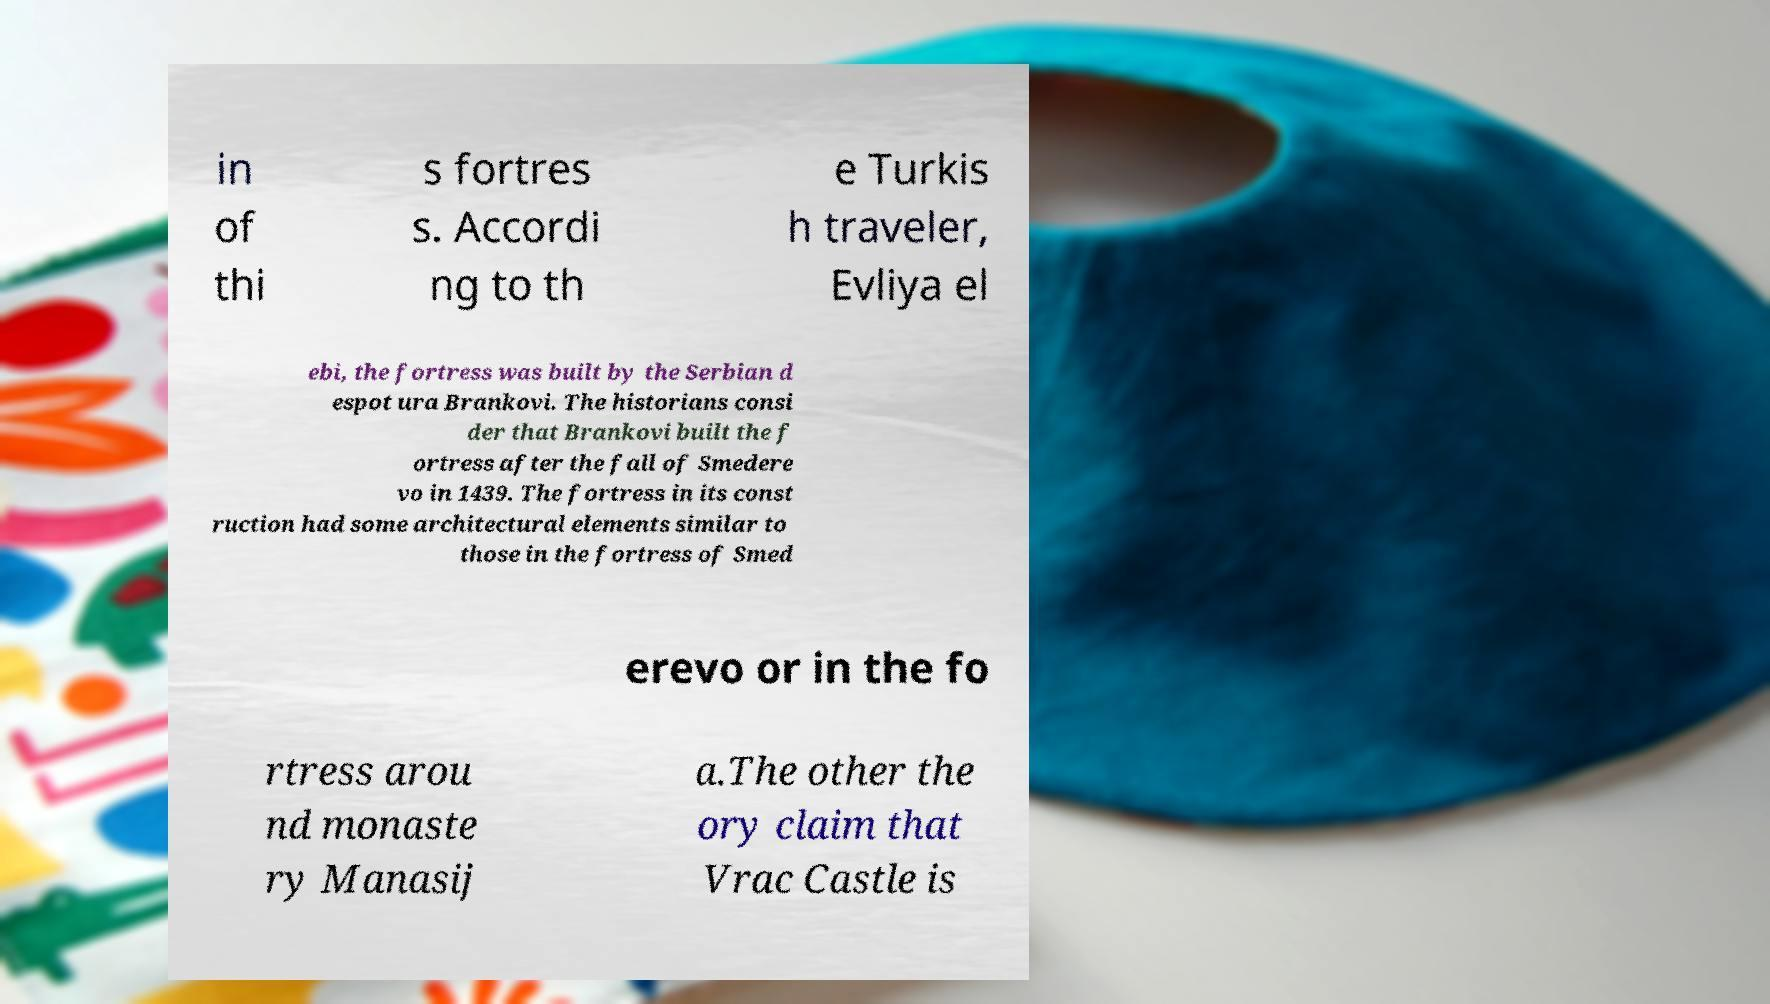Can you accurately transcribe the text from the provided image for me? in of thi s fortres s. Accordi ng to th e Turkis h traveler, Evliya el ebi, the fortress was built by the Serbian d espot ura Brankovi. The historians consi der that Brankovi built the f ortress after the fall of Smedere vo in 1439. The fortress in its const ruction had some architectural elements similar to those in the fortress of Smed erevo or in the fo rtress arou nd monaste ry Manasij a.The other the ory claim that Vrac Castle is 